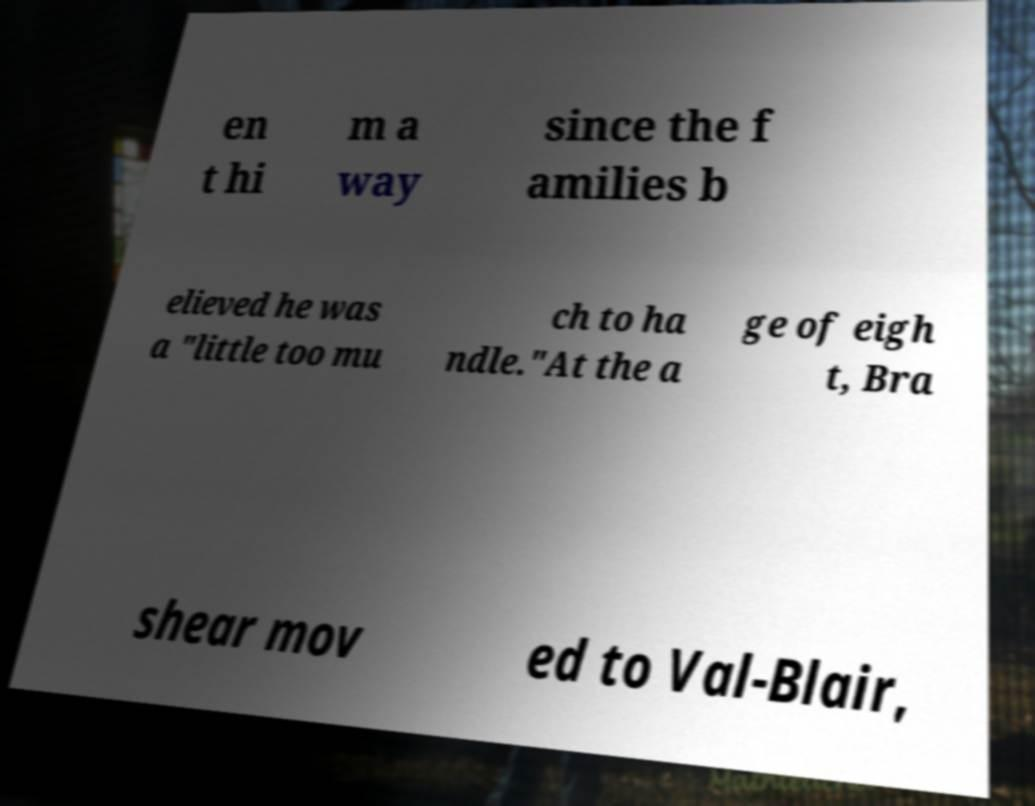Could you assist in decoding the text presented in this image and type it out clearly? en t hi m a way since the f amilies b elieved he was a "little too mu ch to ha ndle."At the a ge of eigh t, Bra shear mov ed to Val-Blair, 